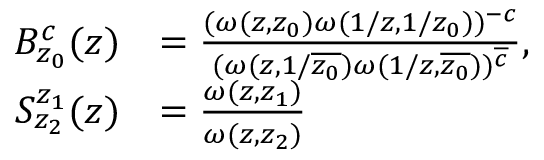Convert formula to latex. <formula><loc_0><loc_0><loc_500><loc_500>\begin{array} { r l } { B _ { z _ { 0 } } ^ { c } ( z ) } & { = \frac { ( \omega ( z , z _ { 0 } ) \omega ( 1 / z , 1 / z _ { 0 } ) ) ^ { - c } } { ( \omega ( z , 1 / \overline { { z _ { 0 } } } ) \omega ( 1 / z , \overline { { z _ { 0 } } } ) ) ^ { \overline { c } } } , } \\ { S _ { z _ { 2 } } ^ { z _ { 1 } } ( z ) } & { = \frac { \omega ( z , z _ { 1 } ) } { \omega ( z , z _ { 2 } ) } } \end{array}</formula> 